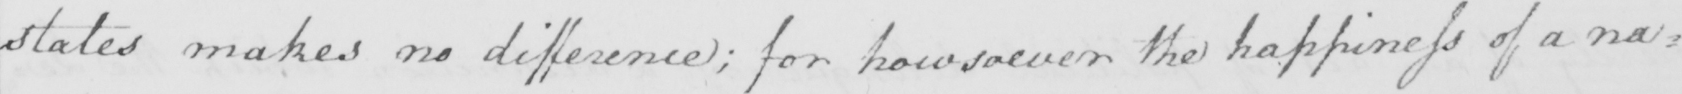Can you tell me what this handwritten text says? states makes no difference ; for howsoever the happiness of a na= 